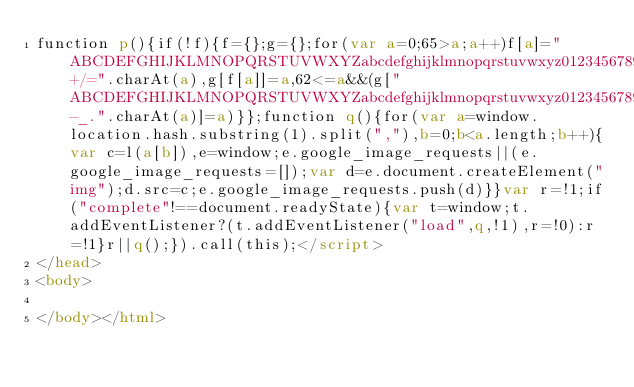Convert code to text. <code><loc_0><loc_0><loc_500><loc_500><_HTML_>function p(){if(!f){f={};g={};for(var a=0;65>a;a++)f[a]="ABCDEFGHIJKLMNOPQRSTUVWXYZabcdefghijklmnopqrstuvwxyz0123456789+/=".charAt(a),g[f[a]]=a,62<=a&&(g["ABCDEFGHIJKLMNOPQRSTUVWXYZabcdefghijklmnopqrstuvwxyz0123456789-_.".charAt(a)]=a)}};function q(){for(var a=window.location.hash.substring(1).split(","),b=0;b<a.length;b++){var c=l(a[b]),e=window;e.google_image_requests||(e.google_image_requests=[]);var d=e.document.createElement("img");d.src=c;e.google_image_requests.push(d)}}var r=!1;if("complete"!==document.readyState){var t=window;t.addEventListener?(t.addEventListener("load",q,!1),r=!0):r=!1}r||q();}).call(this);</script>
</head>
<body>

</body></html></code> 